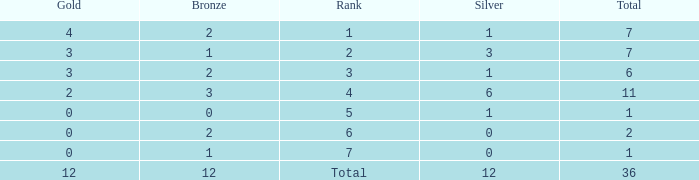What is the largest total for a team with 1 bronze, 0 gold medals and ranking of 7? None. 